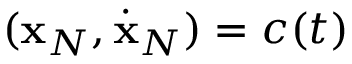Convert formula to latex. <formula><loc_0><loc_0><loc_500><loc_500>( { x } _ { N } , \dot { x } _ { N } ) = c ( t )</formula> 